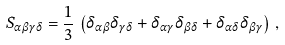<formula> <loc_0><loc_0><loc_500><loc_500>S _ { \alpha \beta \gamma \delta } = \frac { 1 } { 3 } \, \left ( \delta _ { \alpha \beta } \delta _ { \gamma \delta } + \delta _ { \alpha \gamma } \delta _ { \beta \delta } + \delta _ { \alpha \delta } \delta _ { \beta \gamma } \right ) \, ,</formula> 